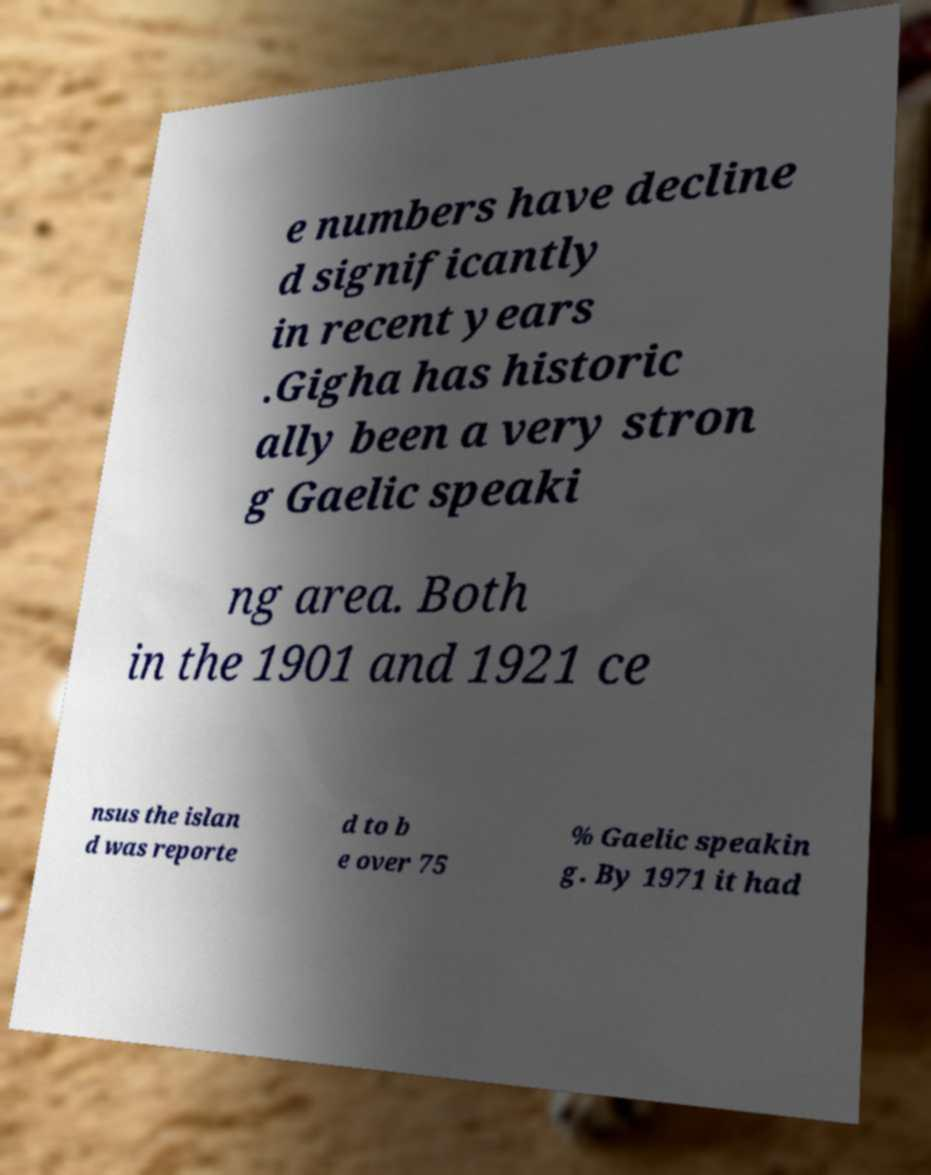Could you extract and type out the text from this image? e numbers have decline d significantly in recent years .Gigha has historic ally been a very stron g Gaelic speaki ng area. Both in the 1901 and 1921 ce nsus the islan d was reporte d to b e over 75 % Gaelic speakin g. By 1971 it had 